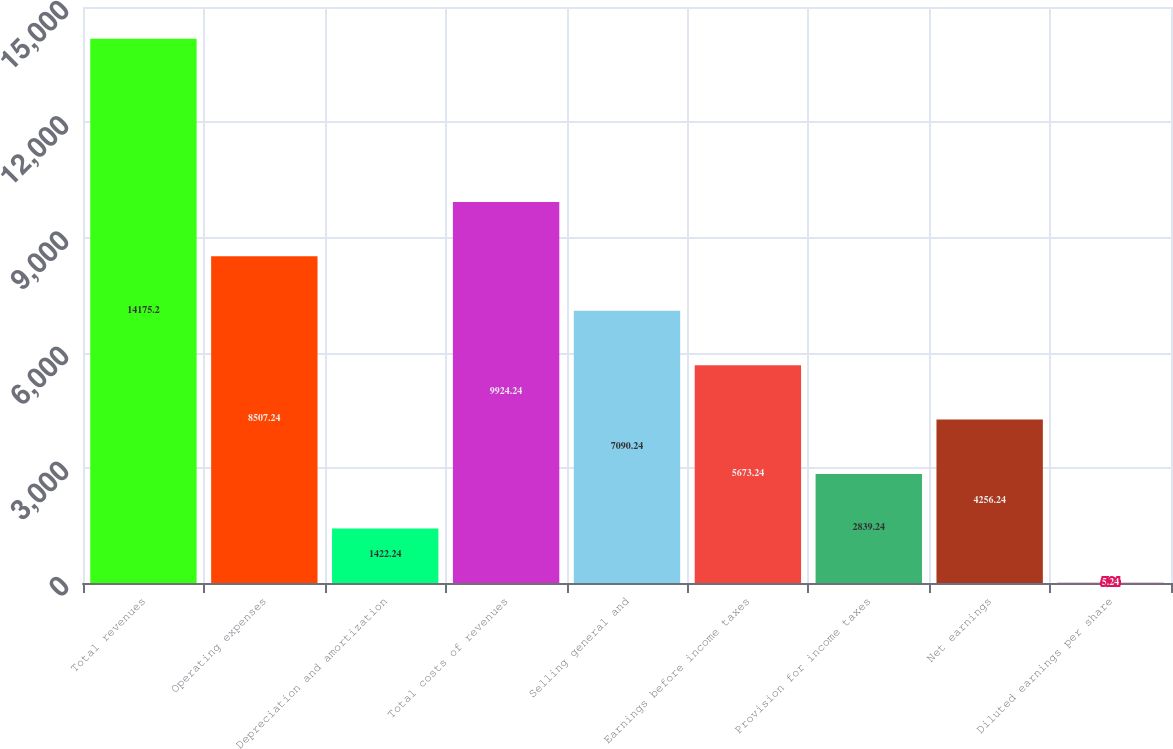<chart> <loc_0><loc_0><loc_500><loc_500><bar_chart><fcel>Total revenues<fcel>Operating expenses<fcel>Depreciation and amortization<fcel>Total costs of revenues<fcel>Selling general and<fcel>Earnings before income taxes<fcel>Provision for income taxes<fcel>Net earnings<fcel>Diluted earnings per share<nl><fcel>14175.2<fcel>8507.24<fcel>1422.24<fcel>9924.24<fcel>7090.24<fcel>5673.24<fcel>2839.24<fcel>4256.24<fcel>5.24<nl></chart> 